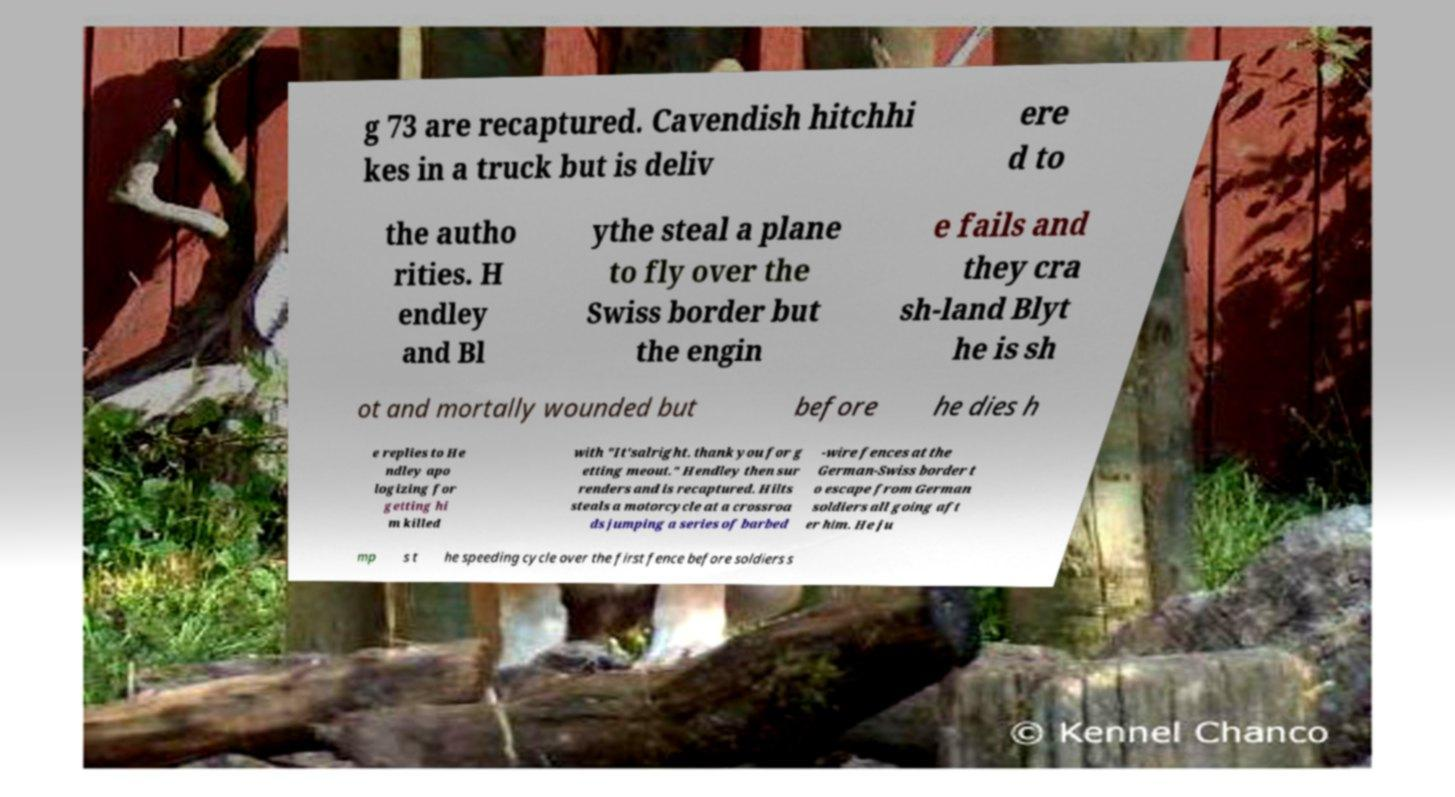I need the written content from this picture converted into text. Can you do that? g 73 are recaptured. Cavendish hitchhi kes in a truck but is deliv ere d to the autho rities. H endley and Bl ythe steal a plane to fly over the Swiss border but the engin e fails and they cra sh-land Blyt he is sh ot and mortally wounded but before he dies h e replies to He ndley apo logizing for getting hi m killed with "It'salright. thank you for g etting meout." Hendley then sur renders and is recaptured. Hilts steals a motorcycle at a crossroa ds jumping a series of barbed -wire fences at the German-Swiss border t o escape from German soldiers all going aft er him. He ju mp s t he speeding cycle over the first fence before soldiers s 